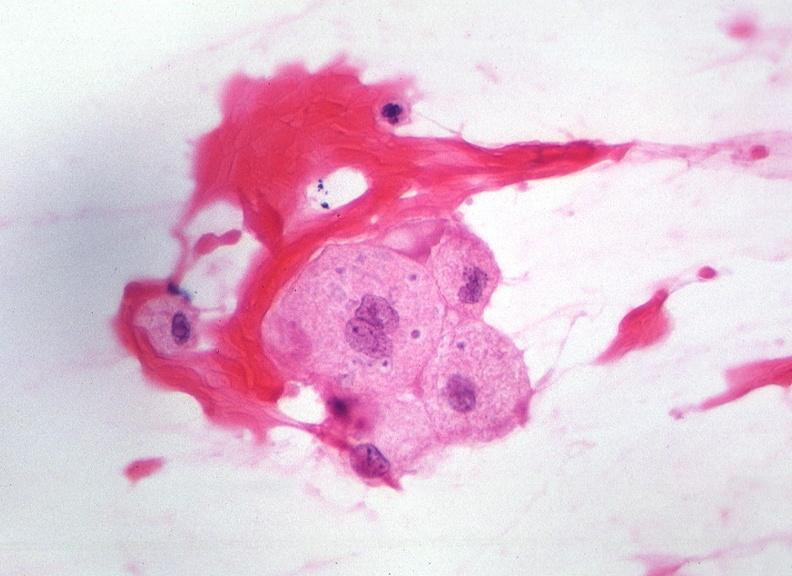s nervous present?
Answer the question using a single word or phrase. Yes 